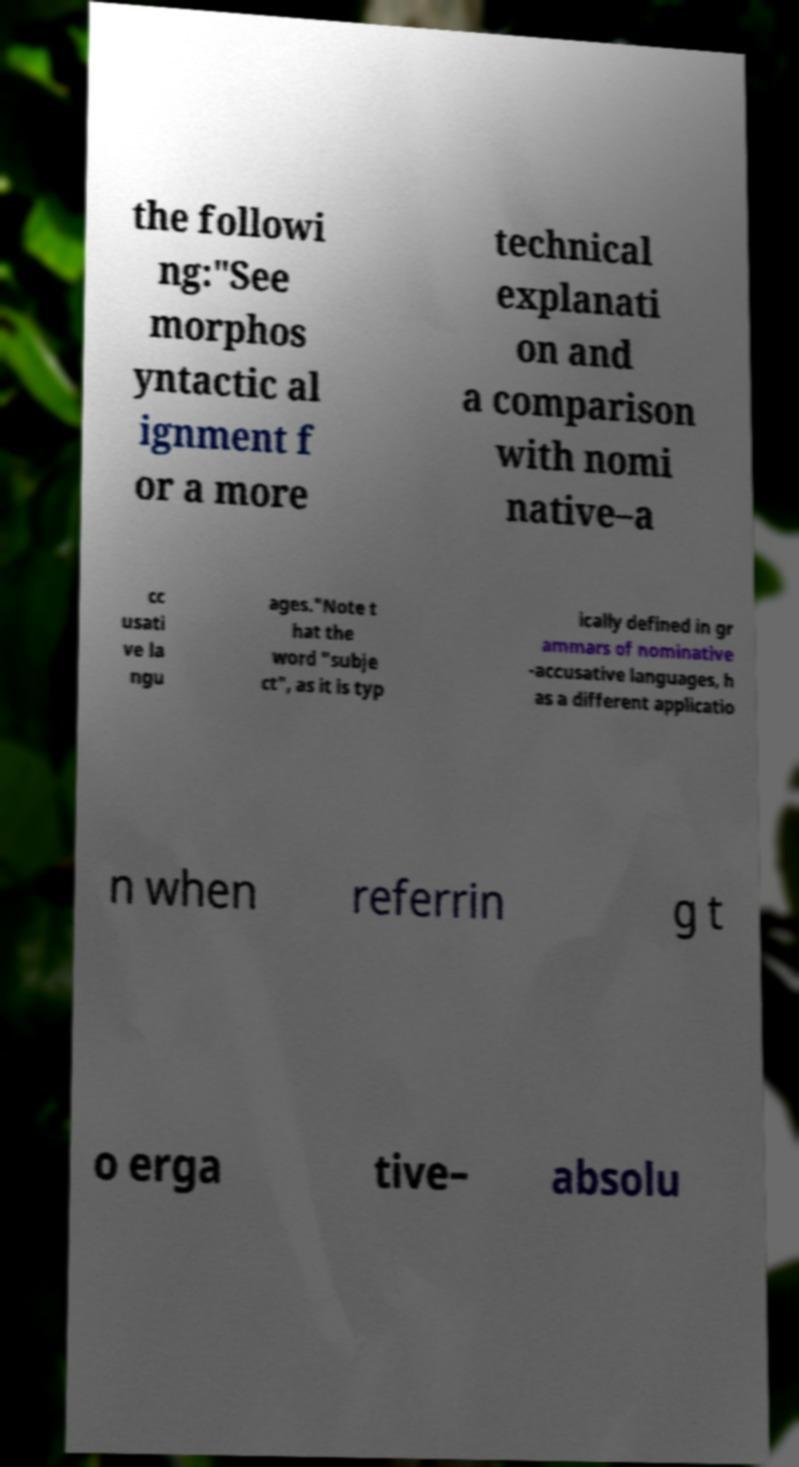Could you assist in decoding the text presented in this image and type it out clearly? the followi ng:"See morphos yntactic al ignment f or a more technical explanati on and a comparison with nomi native–a cc usati ve la ngu ages."Note t hat the word "subje ct", as it is typ ically defined in gr ammars of nominative -accusative languages, h as a different applicatio n when referrin g t o erga tive– absolu 